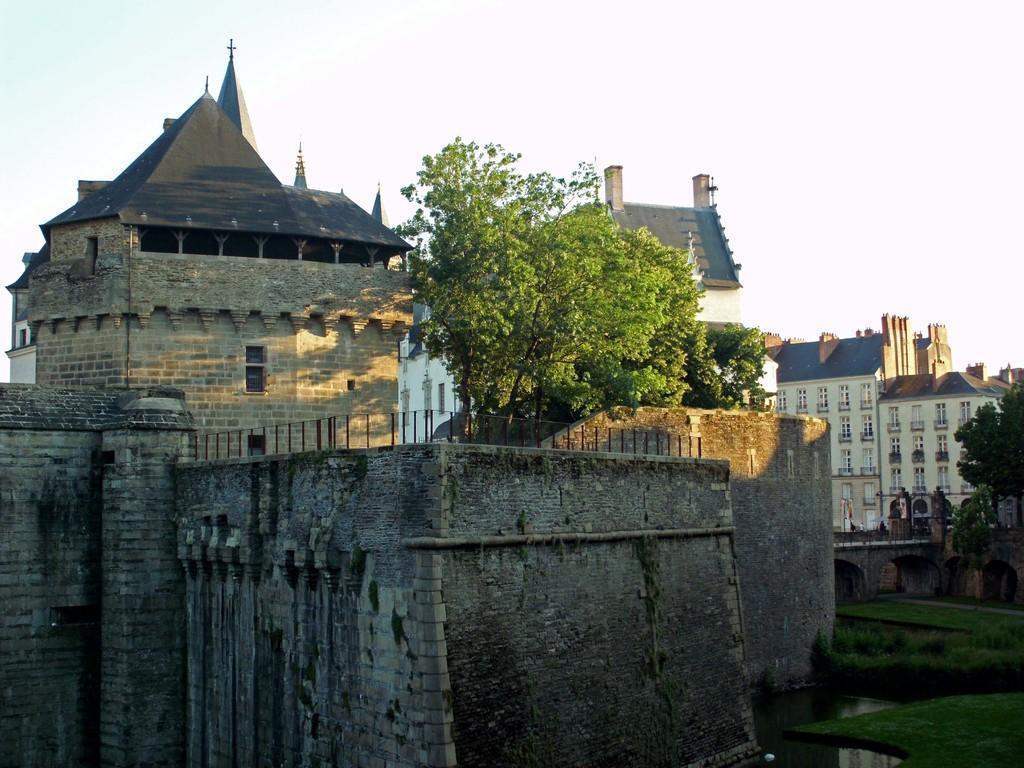How would you summarize this image in a sentence or two? In this image we can see a group of buildings with windows and a roof. We can also see some grass, water, plants, a group of trees and the sky which looks cloudy. 